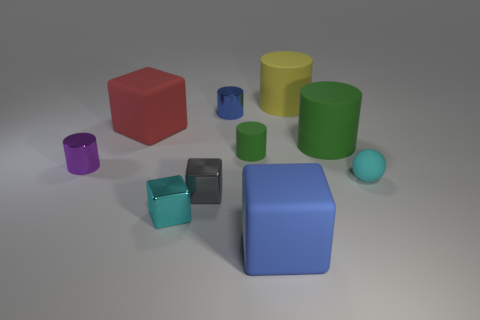Are there any other things that have the same shape as the cyan matte thing?
Your answer should be very brief. No. Do the large blue thing and the large red matte thing have the same shape?
Your answer should be very brief. Yes. Is the number of big green matte cylinders to the right of the big green object the same as the number of small spheres?
Provide a succinct answer. No. The large green rubber thing is what shape?
Your answer should be compact. Cylinder. Is there anything else that is the same color as the matte sphere?
Offer a very short reply. Yes. There is a blue thing behind the small green matte cylinder; is its size the same as the green cylinder that is to the right of the large yellow rubber cylinder?
Offer a terse response. No. There is a green thing to the left of the large cylinder that is in front of the red rubber block; what is its shape?
Your answer should be very brief. Cylinder. Do the gray cube and the cyan object that is to the left of the cyan matte sphere have the same size?
Provide a succinct answer. Yes. There is a rubber cube that is on the left side of the large block in front of the tiny cyan object on the right side of the small gray object; what is its size?
Keep it short and to the point. Large. How many things are either metal things that are to the left of the blue metal object or large gray blocks?
Provide a short and direct response. 3. 